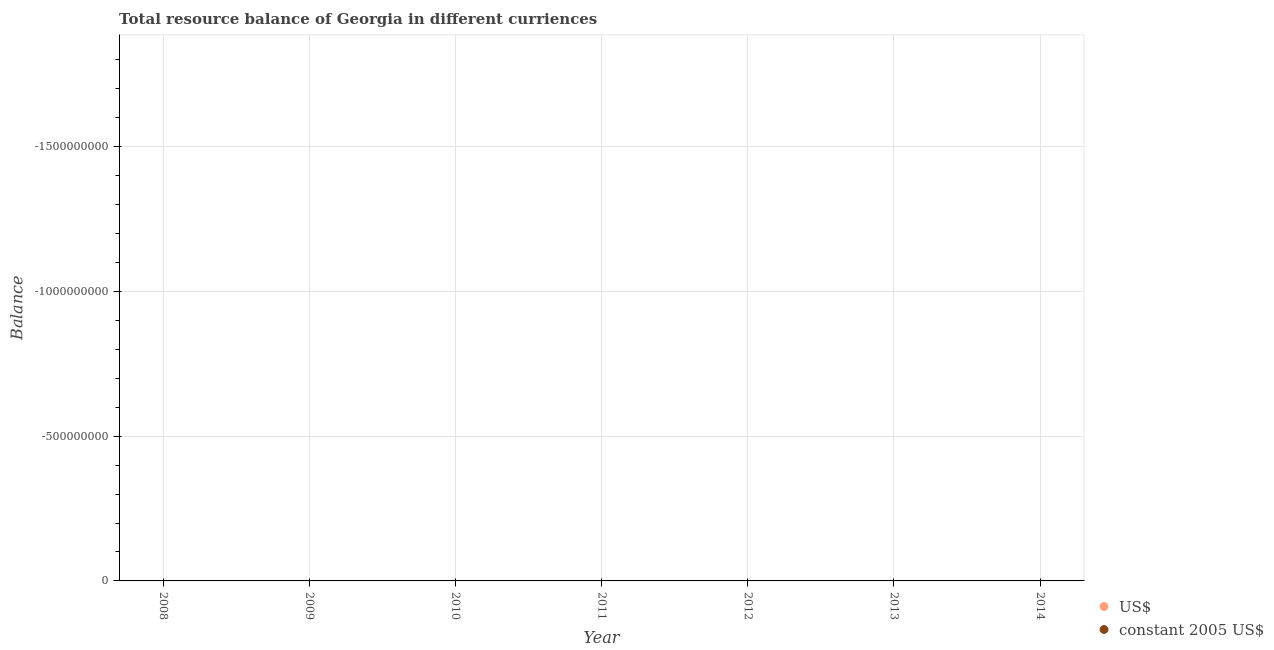Is the number of dotlines equal to the number of legend labels?
Provide a short and direct response. No. What is the resource balance in us$ in 2014?
Ensure brevity in your answer.  0. Across all years, what is the minimum resource balance in constant us$?
Your answer should be compact. 0. What is the total resource balance in constant us$ in the graph?
Your answer should be compact. 0. What is the average resource balance in us$ per year?
Provide a short and direct response. 0. Does the resource balance in constant us$ monotonically increase over the years?
Offer a terse response. No. Is the resource balance in us$ strictly greater than the resource balance in constant us$ over the years?
Keep it short and to the point. No. How many years are there in the graph?
Provide a short and direct response. 7. Does the graph contain any zero values?
Provide a succinct answer. Yes. Does the graph contain grids?
Keep it short and to the point. Yes. Where does the legend appear in the graph?
Offer a very short reply. Bottom right. How are the legend labels stacked?
Keep it short and to the point. Vertical. What is the title of the graph?
Your response must be concise. Total resource balance of Georgia in different curriences. What is the label or title of the X-axis?
Offer a terse response. Year. What is the label or title of the Y-axis?
Your response must be concise. Balance. What is the Balance in constant 2005 US$ in 2008?
Keep it short and to the point. 0. What is the Balance of US$ in 2009?
Your answer should be very brief. 0. What is the Balance in constant 2005 US$ in 2009?
Offer a terse response. 0. What is the Balance of US$ in 2010?
Your response must be concise. 0. What is the Balance in US$ in 2011?
Make the answer very short. 0. What is the Balance in constant 2005 US$ in 2011?
Offer a very short reply. 0. What is the Balance of constant 2005 US$ in 2013?
Offer a very short reply. 0. What is the Balance of US$ in 2014?
Make the answer very short. 0. What is the total Balance of US$ in the graph?
Ensure brevity in your answer.  0. What is the total Balance in constant 2005 US$ in the graph?
Your answer should be very brief. 0. 